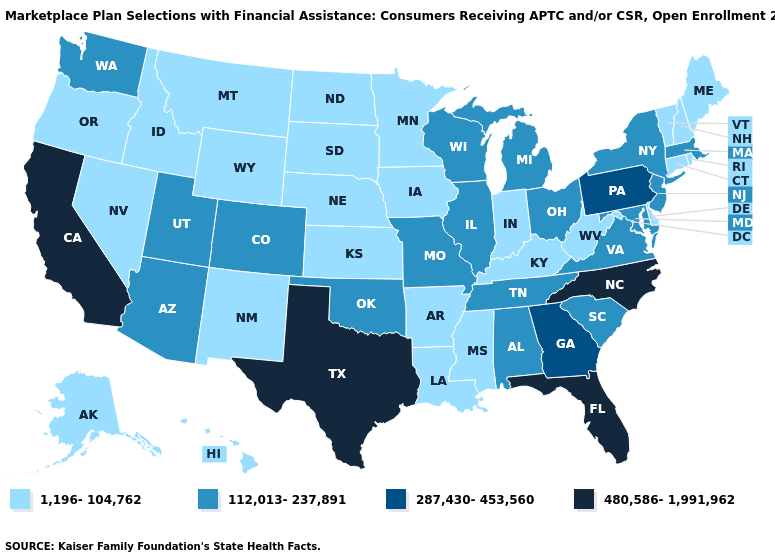Does Connecticut have the lowest value in the USA?
Short answer required. Yes. Which states have the highest value in the USA?
Be succinct. California, Florida, North Carolina, Texas. Among the states that border Iowa , which have the highest value?
Keep it brief. Illinois, Missouri, Wisconsin. Does the first symbol in the legend represent the smallest category?
Give a very brief answer. Yes. What is the highest value in the MidWest ?
Be succinct. 112,013-237,891. Does Hawaii have the lowest value in the West?
Answer briefly. Yes. What is the highest value in the West ?
Keep it brief. 480,586-1,991,962. What is the highest value in the USA?
Write a very short answer. 480,586-1,991,962. What is the value of Rhode Island?
Be succinct. 1,196-104,762. Name the states that have a value in the range 480,586-1,991,962?
Keep it brief. California, Florida, North Carolina, Texas. What is the value of Rhode Island?
Concise answer only. 1,196-104,762. What is the value of North Dakota?
Keep it brief. 1,196-104,762. Does West Virginia have the lowest value in the USA?
Be succinct. Yes. Name the states that have a value in the range 1,196-104,762?
Give a very brief answer. Alaska, Arkansas, Connecticut, Delaware, Hawaii, Idaho, Indiana, Iowa, Kansas, Kentucky, Louisiana, Maine, Minnesota, Mississippi, Montana, Nebraska, Nevada, New Hampshire, New Mexico, North Dakota, Oregon, Rhode Island, South Dakota, Vermont, West Virginia, Wyoming. What is the value of Mississippi?
Give a very brief answer. 1,196-104,762. 